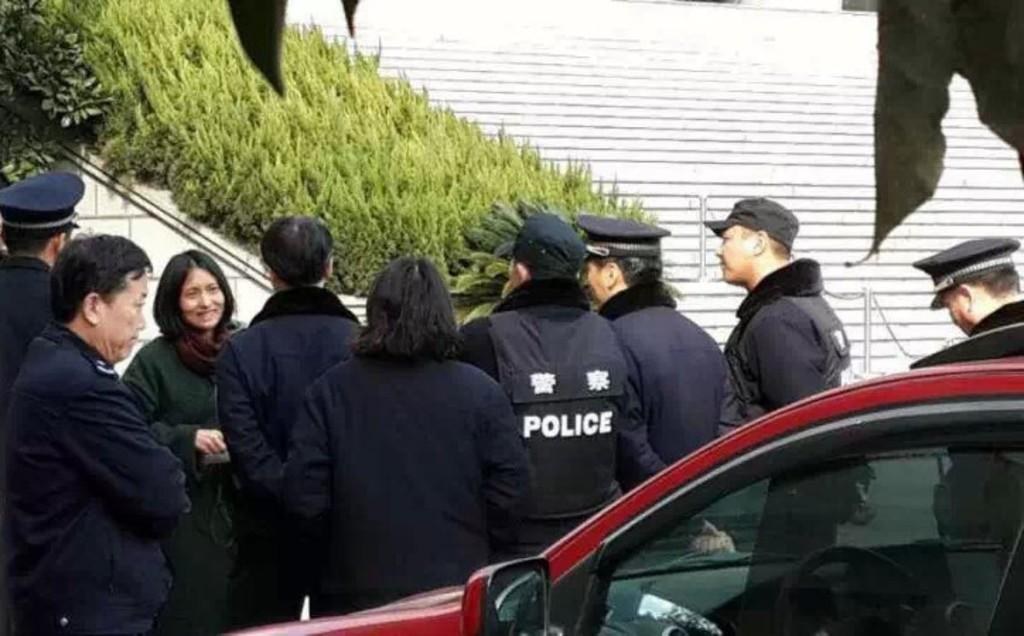How many people are in the image? There is a group of people in the image. What are the people in the image doing? The people are standing. What is located beside the group of people? There is a car beside the group of people. What can be seen in the background of the image? There is grass and metal rods in the background of the image. What type of pleasure can be seen on the thumb of the person in the image? There is no thumb or pleasure present in the image; it features a group of people standing with a car beside them and grass and metal rods in the background. 